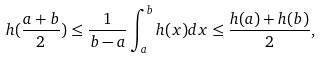<formula> <loc_0><loc_0><loc_500><loc_500>h ( \frac { a + b } 2 ) \leq \frac { 1 } { b - a } \int ^ { b } _ { a } h ( x ) d x \leq \frac { h ( a ) + h ( b ) } { 2 } ,</formula> 